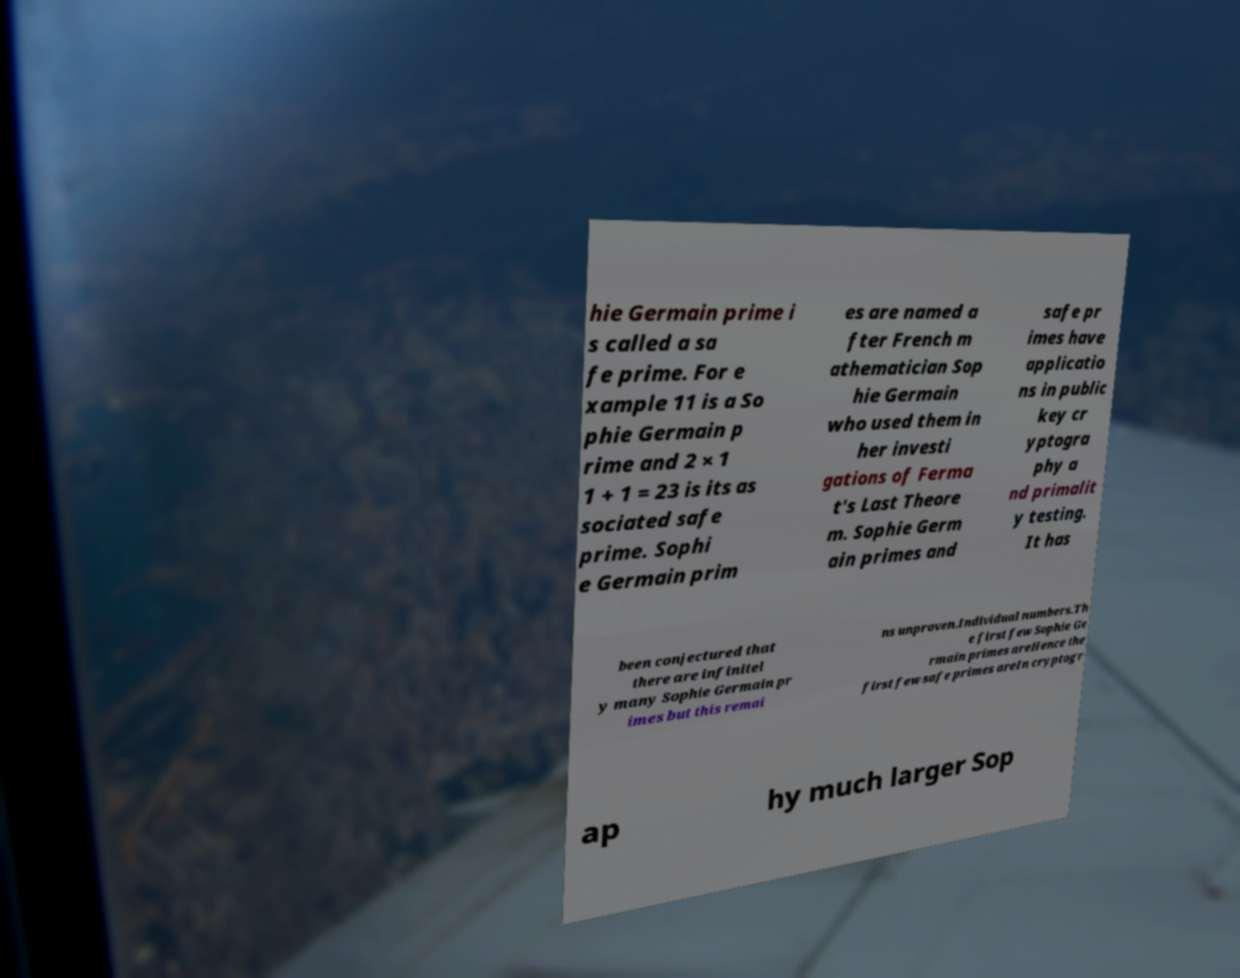Can you read and provide the text displayed in the image?This photo seems to have some interesting text. Can you extract and type it out for me? hie Germain prime i s called a sa fe prime. For e xample 11 is a So phie Germain p rime and 2 × 1 1 + 1 = 23 is its as sociated safe prime. Sophi e Germain prim es are named a fter French m athematician Sop hie Germain who used them in her investi gations of Ferma t's Last Theore m. Sophie Germ ain primes and safe pr imes have applicatio ns in public key cr yptogra phy a nd primalit y testing. It has been conjectured that there are infinitel y many Sophie Germain pr imes but this remai ns unproven.Individual numbers.Th e first few Sophie Ge rmain primes areHence the first few safe primes areIn cryptogr ap hy much larger Sop 